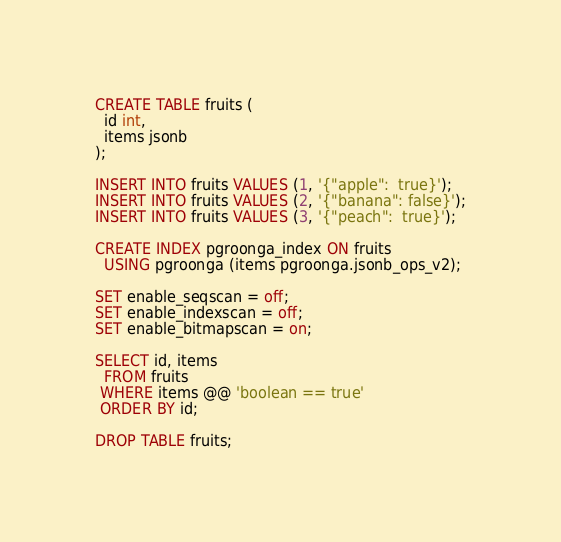Convert code to text. <code><loc_0><loc_0><loc_500><loc_500><_SQL_>CREATE TABLE fruits (
  id int,
  items jsonb
);

INSERT INTO fruits VALUES (1, '{"apple":  true}');
INSERT INTO fruits VALUES (2, '{"banana": false}');
INSERT INTO fruits VALUES (3, '{"peach":  true}');

CREATE INDEX pgroonga_index ON fruits
  USING pgroonga (items pgroonga.jsonb_ops_v2);

SET enable_seqscan = off;
SET enable_indexscan = off;
SET enable_bitmapscan = on;

SELECT id, items
  FROM fruits
 WHERE items @@ 'boolean == true'
 ORDER BY id;

DROP TABLE fruits;
</code> 